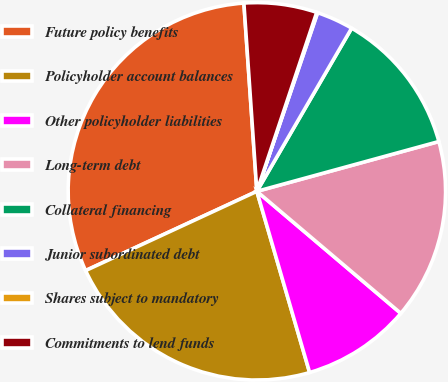Convert chart to OTSL. <chart><loc_0><loc_0><loc_500><loc_500><pie_chart><fcel>Future policy benefits<fcel>Policyholder account balances<fcel>Other policyholder liabilities<fcel>Long-term debt<fcel>Collateral financing<fcel>Junior subordinated debt<fcel>Shares subject to mandatory<fcel>Commitments to lend funds<nl><fcel>30.8%<fcel>22.61%<fcel>9.3%<fcel>15.44%<fcel>12.37%<fcel>3.16%<fcel>0.08%<fcel>6.23%<nl></chart> 